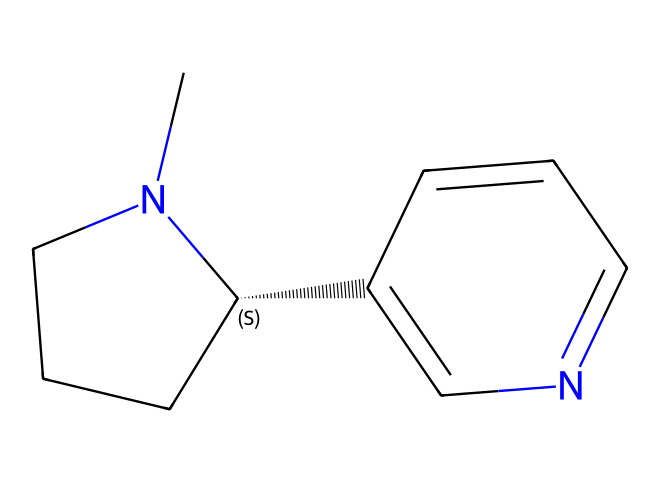how many carbon atoms are in nicotine? By analyzing the SMILES representation (CN1CCC[C@H]1C2=CN=CC=C2), we can count the carbon (C) symbols. There are 10 carbon atoms present in the structure.
Answer: 10 how many nitrogen atoms are in nicotine? In the given SMILES representation, there are two nitrogen (N) symbols, indicating the presence of two nitrogen atoms in the chemical structure of nicotine.
Answer: 2 what type of compound is nicotine? Nicotine belongs to the class of compounds known as alkaloids, characterized by the presence of nitrogen and derived from plants. The presence of the nitrogen atom in the structure confirms this classification.
Answer: alkaloid what is the molecular formula of nicotine? To derive the molecular formula from the SMILES representation, we identify the total number of each type of atom in the compound. Nicotine has 10 carbons, 14 hydrogens, and 2 nitrogens, giving us the molecular formula C10H14N2.
Answer: C10H14N2 is nicotine a stimulant? Based on known pharmacological properties and the presence of nitrogen in the structure, nicotine is classified as a stimulant, as it affects the central nervous system and increases alertness.
Answer: yes which part of nicotine is associated with its stimulant properties? The nitrogen atom plays a significant role in nicotine's interaction with nicotinic acetylcholine receptors, contributing to its stimulant effects. The structure shows this nitrogen, which is crucial for its pharmacological activity.
Answer: nitrogen 